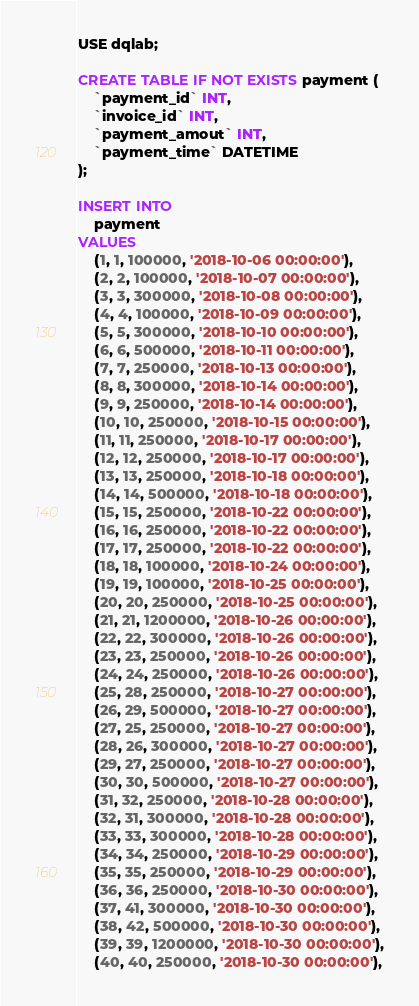Convert code to text. <code><loc_0><loc_0><loc_500><loc_500><_SQL_>USE dqlab;

CREATE TABLE IF NOT EXISTS payment (
    `payment_id` INT,
    `invoice_id` INT,
    `payment_amout` INT,
    `payment_time` DATETIME
);

INSERT INTO
    payment
VALUES
    (1, 1, 100000, '2018-10-06 00:00:00'),
    (2, 2, 100000, '2018-10-07 00:00:00'),
    (3, 3, 300000, '2018-10-08 00:00:00'),
    (4, 4, 100000, '2018-10-09 00:00:00'),
    (5, 5, 300000, '2018-10-10 00:00:00'),
    (6, 6, 500000, '2018-10-11 00:00:00'),
    (7, 7, 250000, '2018-10-13 00:00:00'),
    (8, 8, 300000, '2018-10-14 00:00:00'),
    (9, 9, 250000, '2018-10-14 00:00:00'),
    (10, 10, 250000, '2018-10-15 00:00:00'),
    (11, 11, 250000, '2018-10-17 00:00:00'),
    (12, 12, 250000, '2018-10-17 00:00:00'),
    (13, 13, 250000, '2018-10-18 00:00:00'),
    (14, 14, 500000, '2018-10-18 00:00:00'),
    (15, 15, 250000, '2018-10-22 00:00:00'),
    (16, 16, 250000, '2018-10-22 00:00:00'),
    (17, 17, 250000, '2018-10-22 00:00:00'),
    (18, 18, 100000, '2018-10-24 00:00:00'),
    (19, 19, 100000, '2018-10-25 00:00:00'),
    (20, 20, 250000, '2018-10-25 00:00:00'),
    (21, 21, 1200000, '2018-10-26 00:00:00'),
    (22, 22, 300000, '2018-10-26 00:00:00'),
    (23, 23, 250000, '2018-10-26 00:00:00'),
    (24, 24, 250000, '2018-10-26 00:00:00'),
    (25, 28, 250000, '2018-10-27 00:00:00'),
    (26, 29, 500000, '2018-10-27 00:00:00'),
    (27, 25, 250000, '2018-10-27 00:00:00'),
    (28, 26, 300000, '2018-10-27 00:00:00'),
    (29, 27, 250000, '2018-10-27 00:00:00'),
    (30, 30, 500000, '2018-10-27 00:00:00'),
    (31, 32, 250000, '2018-10-28 00:00:00'),
    (32, 31, 300000, '2018-10-28 00:00:00'),
    (33, 33, 300000, '2018-10-28 00:00:00'),
    (34, 34, 250000, '2018-10-29 00:00:00'),
    (35, 35, 250000, '2018-10-29 00:00:00'),
    (36, 36, 250000, '2018-10-30 00:00:00'),
    (37, 41, 300000, '2018-10-30 00:00:00'),
    (38, 42, 500000, '2018-10-30 00:00:00'),
    (39, 39, 1200000, '2018-10-30 00:00:00'),
    (40, 40, 250000, '2018-10-30 00:00:00'),</code> 